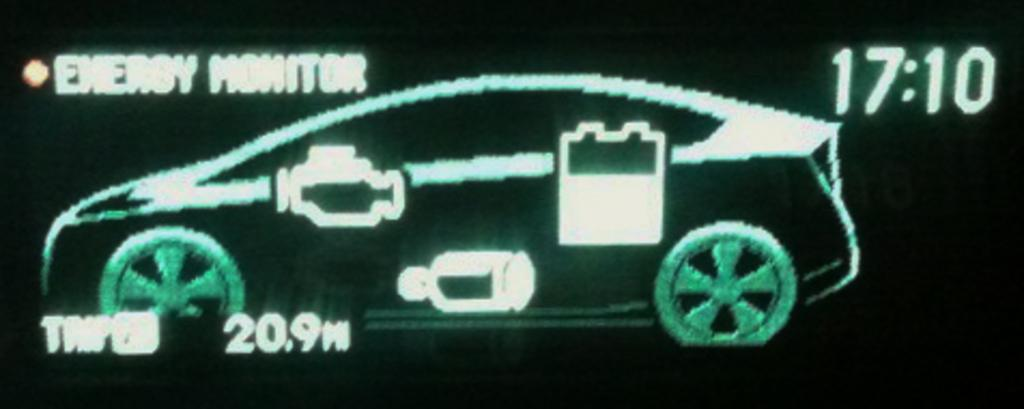What is the main subject of the image? There is a car in the image. What else can be seen in the image besides the car? There are numbers and letters in the image. Are there any snails crawling on the car in the image? There is no mention of snails in the image, so we cannot determine if they are present or not. 